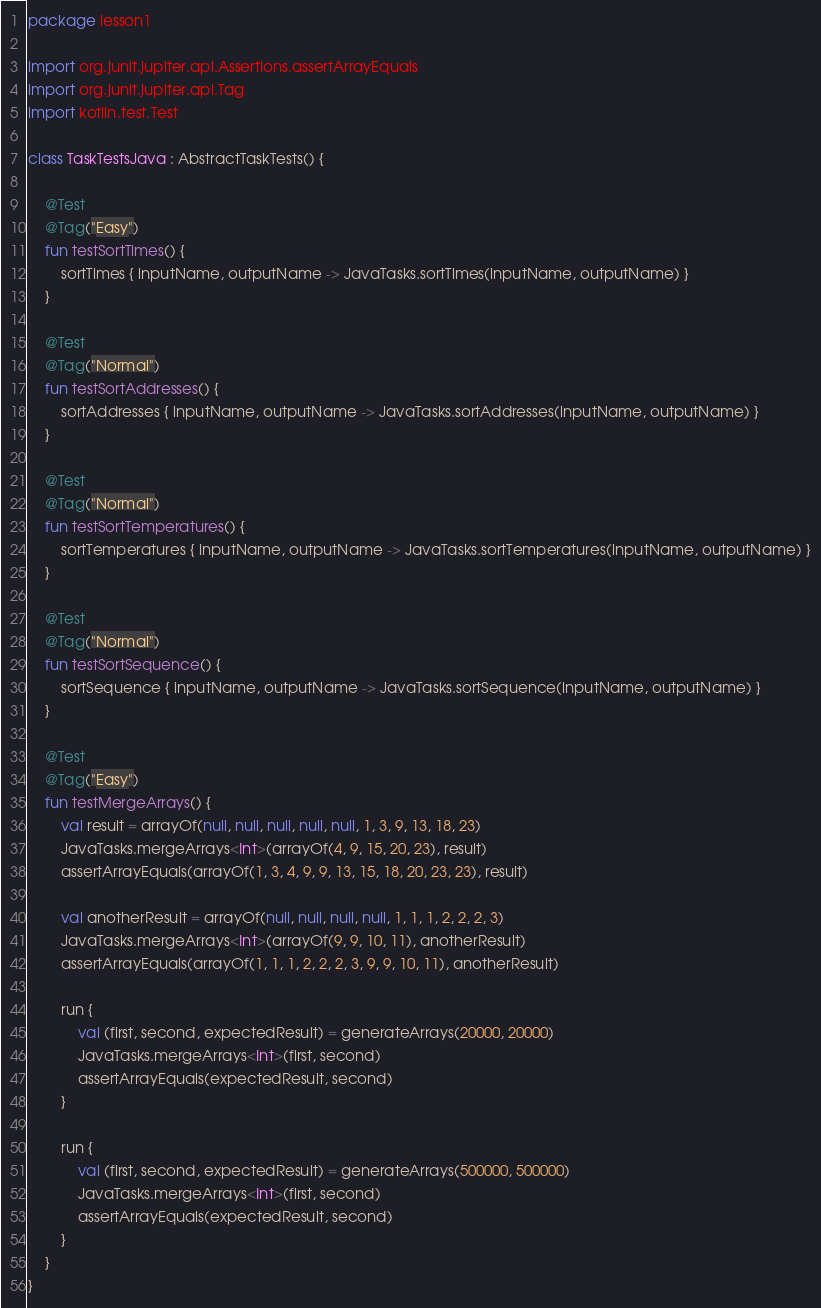Convert code to text. <code><loc_0><loc_0><loc_500><loc_500><_Kotlin_>package lesson1

import org.junit.jupiter.api.Assertions.assertArrayEquals
import org.junit.jupiter.api.Tag
import kotlin.test.Test

class TaskTestsJava : AbstractTaskTests() {

    @Test
    @Tag("Easy")
    fun testSortTimes() {
        sortTimes { inputName, outputName -> JavaTasks.sortTimes(inputName, outputName) }
    }

    @Test
    @Tag("Normal")
    fun testSortAddresses() {
        sortAddresses { inputName, outputName -> JavaTasks.sortAddresses(inputName, outputName) }
    }

    @Test
    @Tag("Normal")
    fun testSortTemperatures() {
        sortTemperatures { inputName, outputName -> JavaTasks.sortTemperatures(inputName, outputName) }
    }

    @Test
    @Tag("Normal")
    fun testSortSequence() {
        sortSequence { inputName, outputName -> JavaTasks.sortSequence(inputName, outputName) }
    }

    @Test
    @Tag("Easy")
    fun testMergeArrays() {
        val result = arrayOf(null, null, null, null, null, 1, 3, 9, 13, 18, 23)
        JavaTasks.mergeArrays<Int>(arrayOf(4, 9, 15, 20, 23), result)
        assertArrayEquals(arrayOf(1, 3, 4, 9, 9, 13, 15, 18, 20, 23, 23), result)

        val anotherResult = arrayOf(null, null, null, null, 1, 1, 1, 2, 2, 2, 3)
        JavaTasks.mergeArrays<Int>(arrayOf(9, 9, 10, 11), anotherResult)
        assertArrayEquals(arrayOf(1, 1, 1, 2, 2, 2, 3, 9, 9, 10, 11), anotherResult)

        run {
            val (first, second, expectedResult) = generateArrays(20000, 20000)
            JavaTasks.mergeArrays<Int>(first, second)
            assertArrayEquals(expectedResult, second)
        }

        run {
            val (first, second, expectedResult) = generateArrays(500000, 500000)
            JavaTasks.mergeArrays<Int>(first, second)
            assertArrayEquals(expectedResult, second)
        }
    }
}</code> 